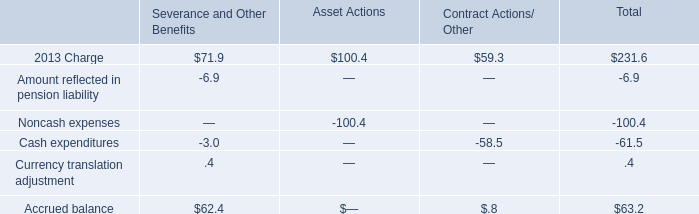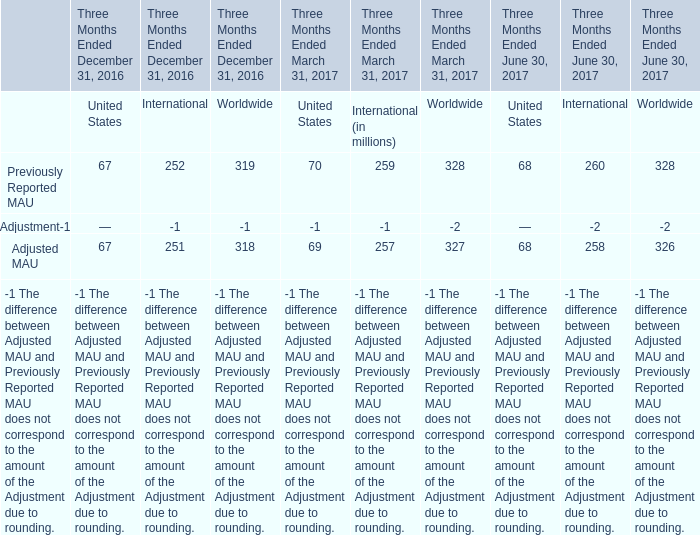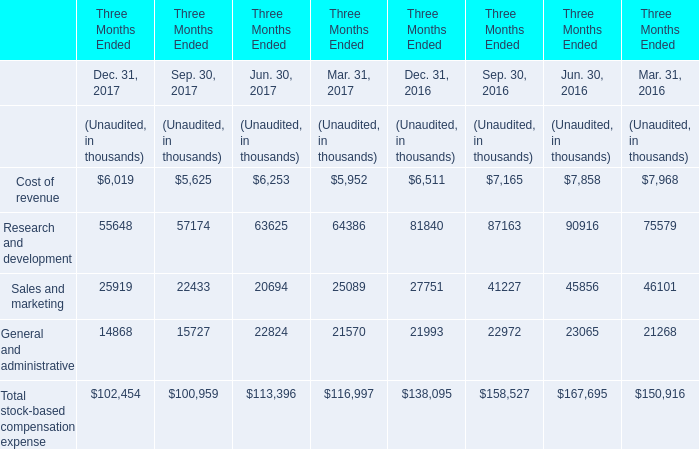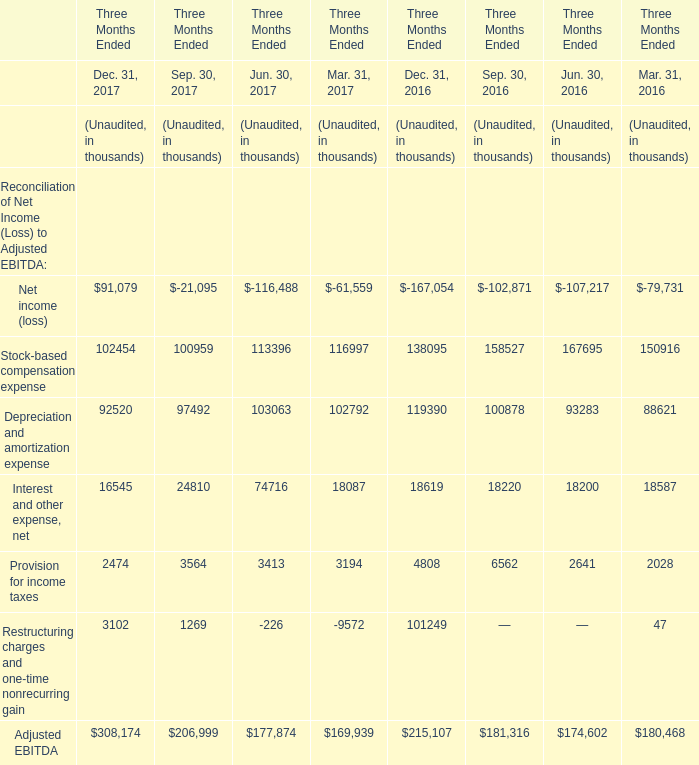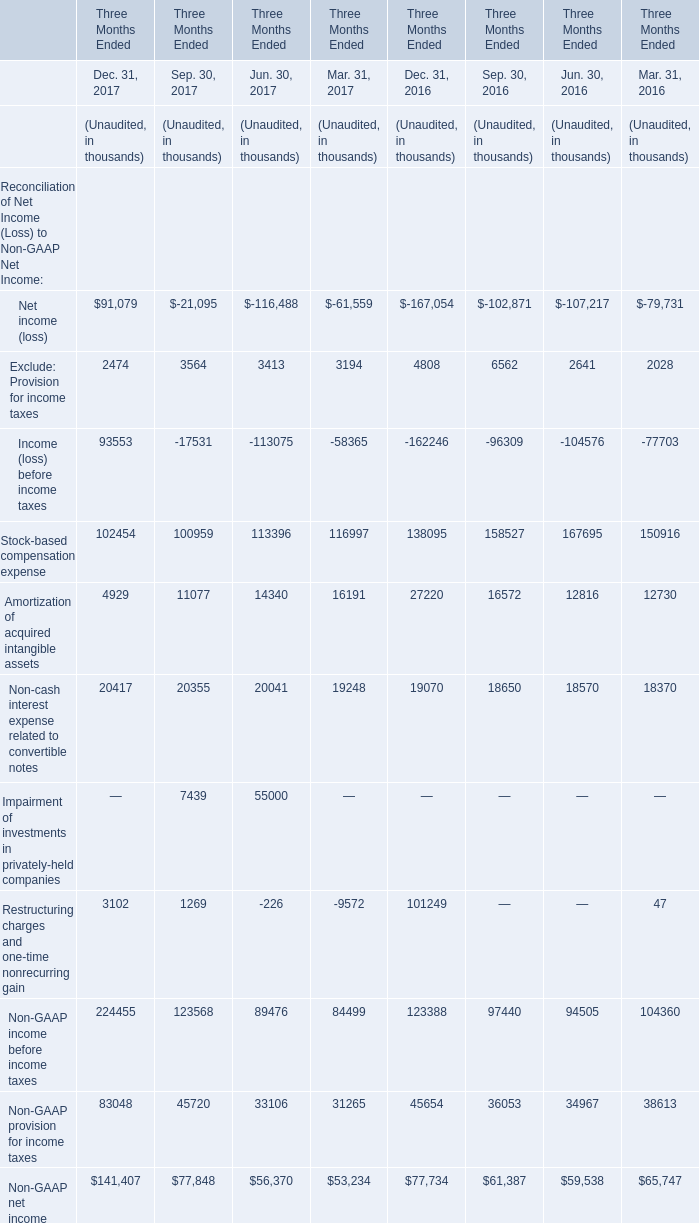Does Depreciation and amortization expense keeps increasing each year between Jun. 30,2016 and Jun. 30, 2017? 
Answer: yes. 